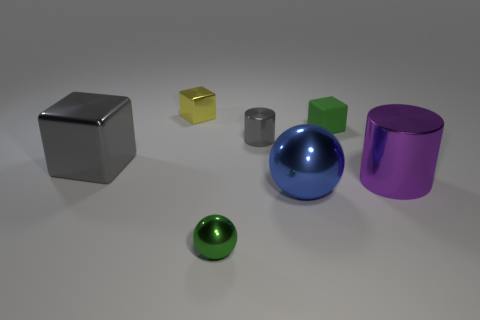Subtract all shiny cubes. How many cubes are left? 1 Subtract all spheres. How many objects are left? 5 Add 2 large blue objects. How many objects exist? 9 Subtract all purple cylinders. How many cylinders are left? 1 Subtract all purple balls. Subtract all purple cylinders. How many balls are left? 2 Subtract all purple spheres. How many green cubes are left? 1 Subtract all purple metal cylinders. Subtract all small yellow shiny blocks. How many objects are left? 5 Add 5 green spheres. How many green spheres are left? 6 Add 1 big blue metallic spheres. How many big blue metallic spheres exist? 2 Subtract 0 red spheres. How many objects are left? 7 